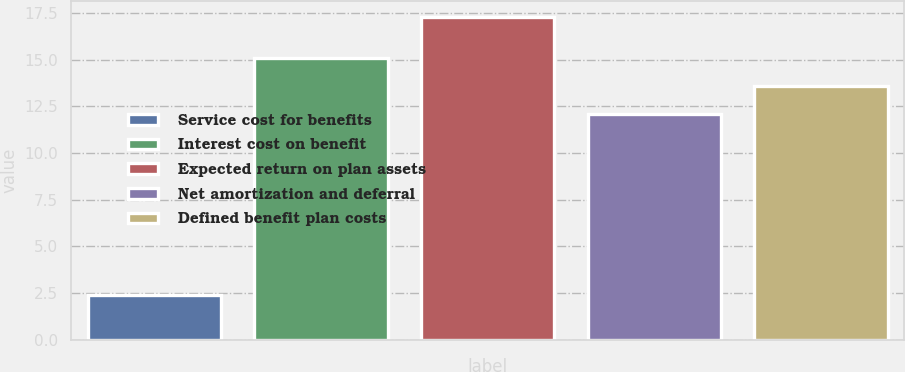<chart> <loc_0><loc_0><loc_500><loc_500><bar_chart><fcel>Service cost for benefits<fcel>Interest cost on benefit<fcel>Expected return on plan assets<fcel>Net amortization and deferral<fcel>Defined benefit plan costs<nl><fcel>2.4<fcel>15.08<fcel>17.3<fcel>12.1<fcel>13.59<nl></chart> 